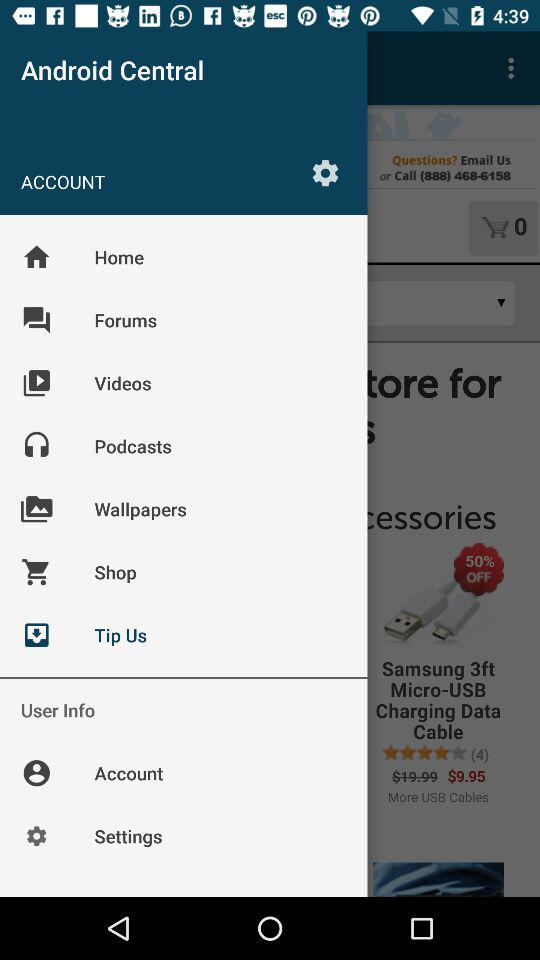What is the name of the application? The name of the application is "Android Central". 